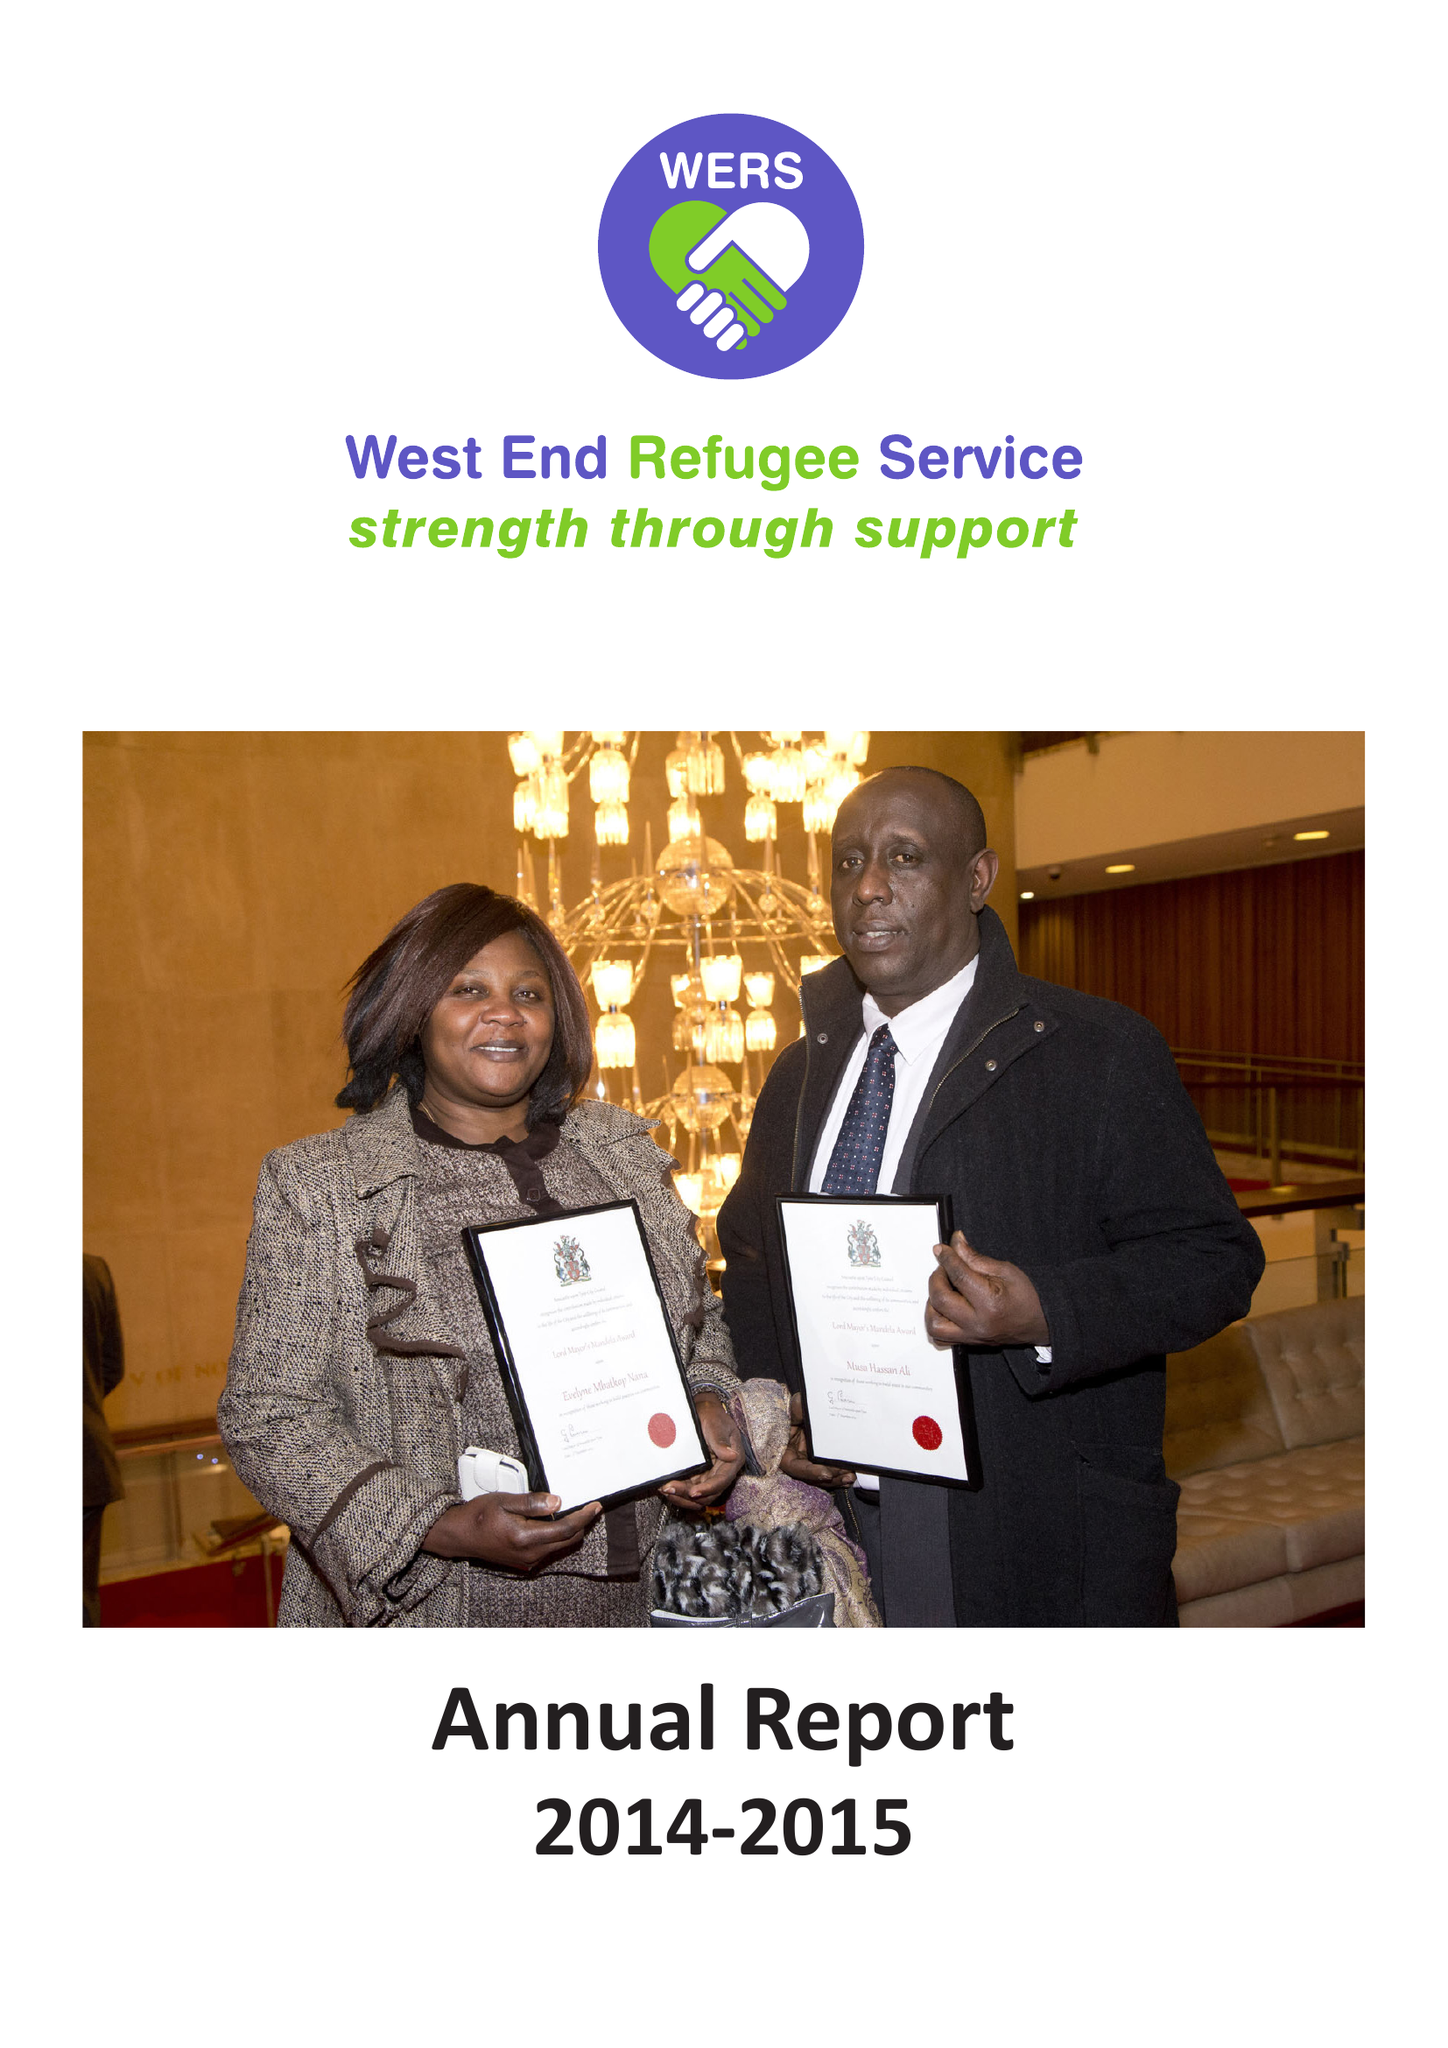What is the value for the income_annually_in_british_pounds?
Answer the question using a single word or phrase. 250113.00 